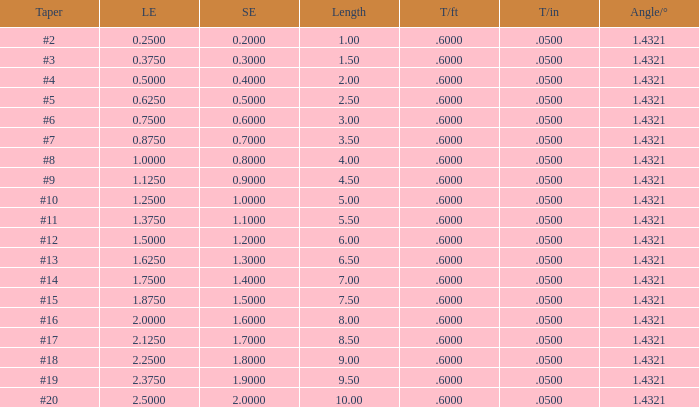Which Taper/in that has a Small end larger than 0.7000000000000001, and a Taper of #19, and a Large end larger than 2.375? None. 